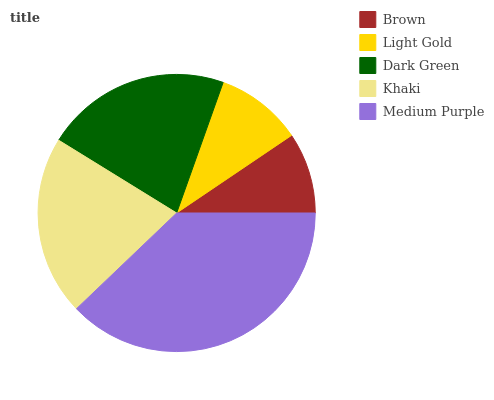Is Brown the minimum?
Answer yes or no. Yes. Is Medium Purple the maximum?
Answer yes or no. Yes. Is Light Gold the minimum?
Answer yes or no. No. Is Light Gold the maximum?
Answer yes or no. No. Is Light Gold greater than Brown?
Answer yes or no. Yes. Is Brown less than Light Gold?
Answer yes or no. Yes. Is Brown greater than Light Gold?
Answer yes or no. No. Is Light Gold less than Brown?
Answer yes or no. No. Is Khaki the high median?
Answer yes or no. Yes. Is Khaki the low median?
Answer yes or no. Yes. Is Dark Green the high median?
Answer yes or no. No. Is Brown the low median?
Answer yes or no. No. 